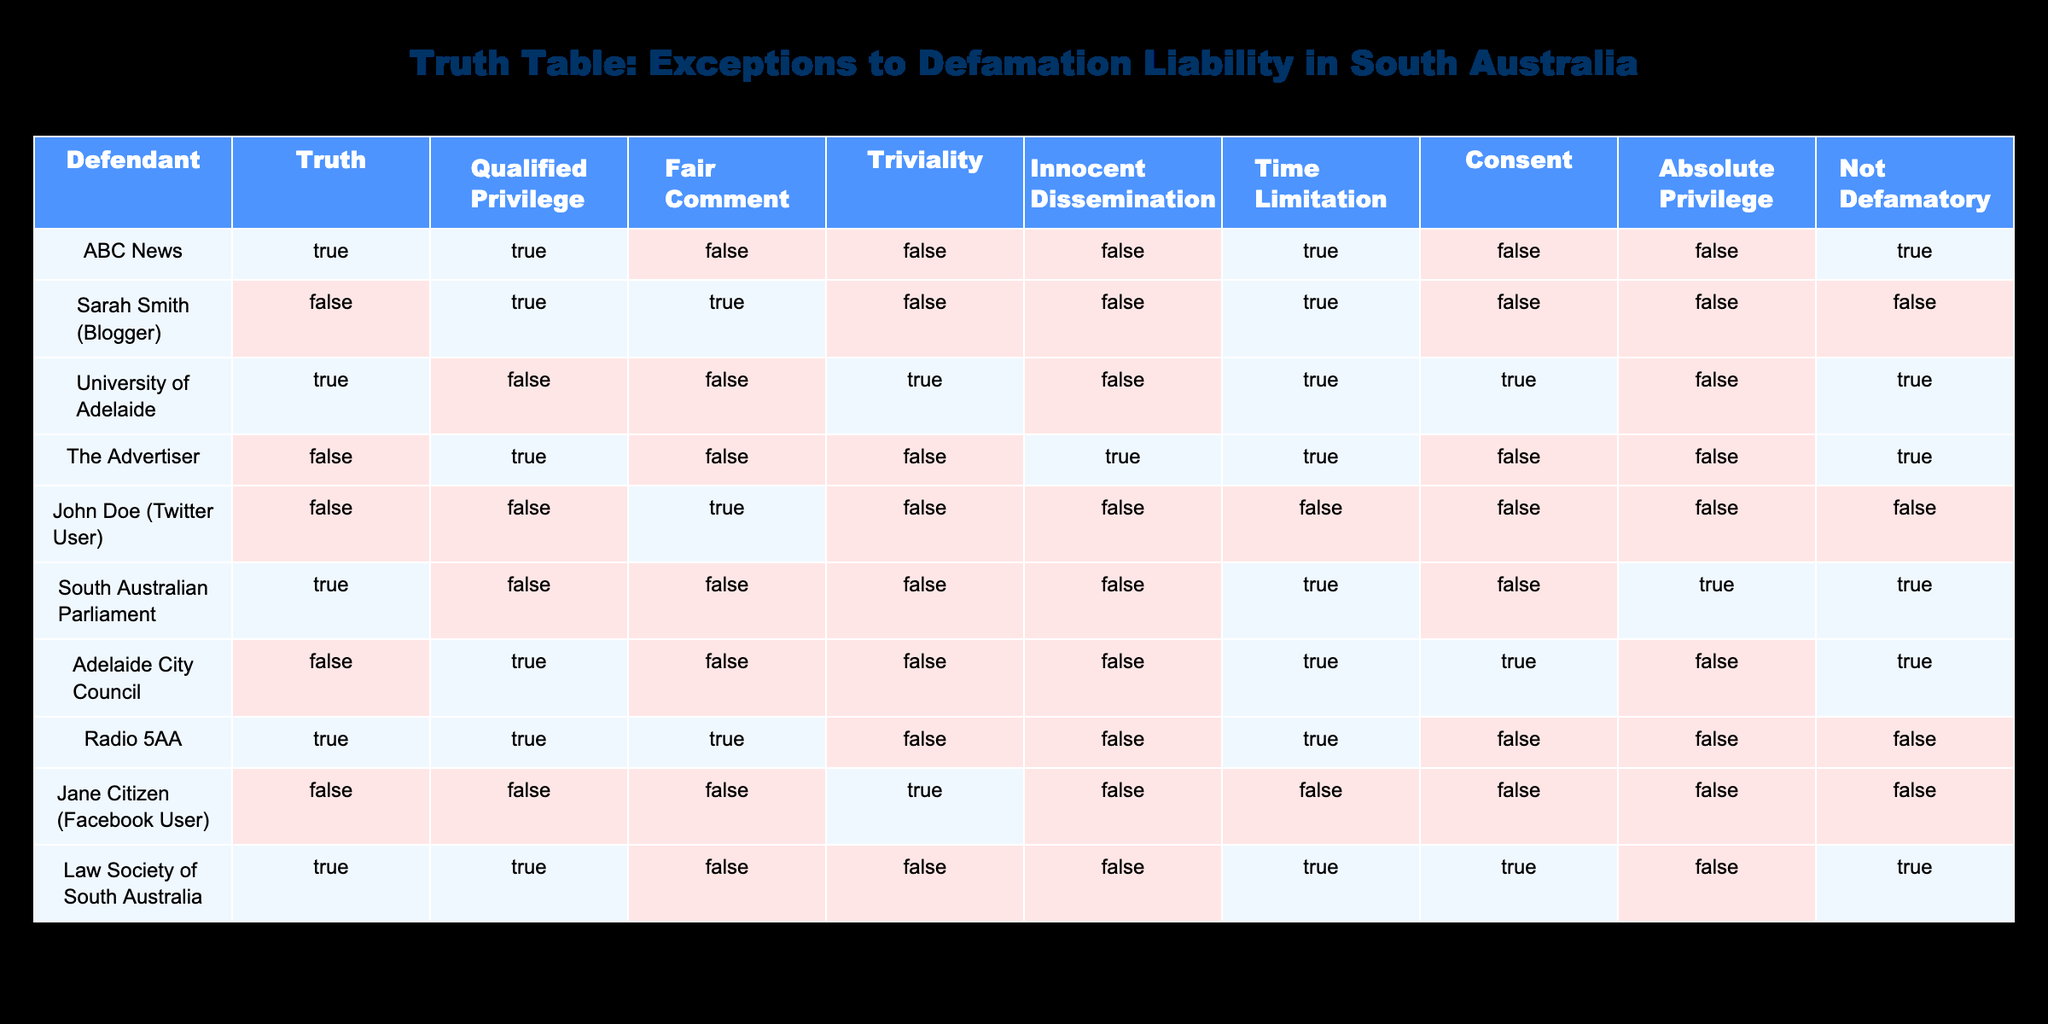What is the status of the University of Adelaide concerning Truth? The table shows that for the University of Adelaide, the value under Truth is TRUE. This indicates that their action is based on truthful information.
Answer: TRUE Which defendant has the exception of Absolute Privilege? By examining the table, both the South Australian Parliament and the University of Adelaide have a value of TRUE under Absolute Privilege.
Answer: South Australian Parliament, University of Adelaide How many defendants have Qualified Privilege? The table lists the defendants with Qualified Privilege as: ABC News, Sarah Smith (Blogger), The Advertiser, Adelaide City Council, and Law Society of South Australia. Counting these gives us five.
Answer: 5 Is Radio 5AA's statement considered Not Defamatory? The table indicates that for Radio 5AA, the value for Not Defamatory is FALSE, meaning their statement is considered defamatory.
Answer: FALSE Which defendants have both Fair Comment and Qualified Privilege? Looking through the table, we find that Sarah Smith (Blogger) is the only defendant that has a TRUE value for both Fair Comment and Qualified Privilege.
Answer: Sarah Smith (Blogger) What is the relationship between Time Limitation and the defendants that have Qualified Privilege? Out of the five defendants with Qualified Privilege (ABC News, Sarah Smith (Blogger), The Advertiser, Adelaide City Council, and Law Society of South Australia), all but ABC News and Adelaide City Council have TRUE values for Time Limitation. This indicates that almost all such defendants are protected from Time Limitations in their statements.
Answer: Almost all have Time Limitation Which statement can be made about the defamation liability status of John Doe (Twitter User)? Analyzing the table, John Doe has FALSE for Truth, Qualified Privilege, Fair Comment, and Innocent Dissemination, implying he has no defenses available and is likely liable for defamation.
Answer: Likely liable How many defendants have at least one exception to defamation liability? By reviewing the table, we see that all defendants except John Doe (Twitter User) have at least one TRUE value under the exceptions; therefore, there are nine defendants with exceptions.
Answer: 9 What combination of exceptions to defamation liability does the Adelaide City Council have? The table shows that Adelaide City Council has TRUE values for Qualified Privilege, Time Limitation, and Consent. Therefore, all these exceptions apply to their case.
Answer: Qualified Privilege, Time Limitation, Consent 